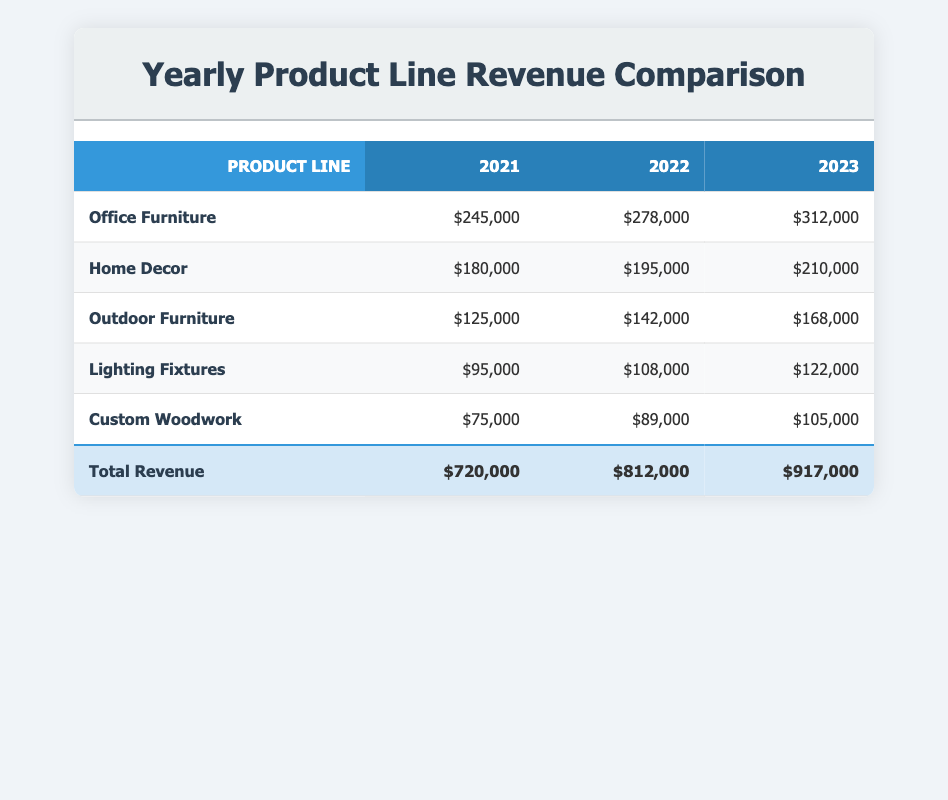What was the revenue from Office Furniture in 2022? The revenue from Office Furniture in 2022 can be directly found in the table under the corresponding product line and year, which shows $278,000.
Answer: $278,000 Which product line had the highest revenue in 2023? By comparing the revenues in the 2023 column for all product lines, Office Furniture has the highest revenue of $312,000.
Answer: Office Furniture What is the total revenue for the year 2022? The total revenue for 2022 is found in the total row of the table, which shows $812,000.
Answer: $812,000 How much did Custom Woodwork revenue increase from 2021 to 2023? The revenue for Custom Woodwork in 2021 is $75,000, and in 2023 it is $105,000. The increase is calculated by subtracting 2021's revenue from 2023's: $105,000 - $75,000 = $30,000.
Answer: $30,000 Is the revenue from Home Decor in 2023 greater than that of Lighting Fixtures in the same year? The revenue for Home Decor in 2023 is $210,000, and for Lighting Fixtures, it is $122,000. Since $210,000 is greater than $122,000, the statement is true.
Answer: Yes What was the average revenue of the Outdoor Furniture product line over the three years? To find the average revenue, first sum the revenues: $125,000 + $142,000 + $168,000 = $435,000. Then divide that by the number of years (3): $435,000 / 3 = $145,000.
Answer: $145,000 Did the total revenue increase from 2021 to 2022? The total revenue in 2021 is $720,000 and in 2022 it is $812,000. Since $812,000 is greater than $720,000, the total revenue did increase.
Answer: Yes What is the difference in revenue between Home Decor in 2023 and Office Furniture in 2021? Home Decor revenue in 2023 is $210,000 and Office Furniture revenue in 2021 is $245,000. The difference can be found by subtracting: $210,000 - $245,000 = -$35,000, indicating Home Decor has less revenue.
Answer: -$35,000 